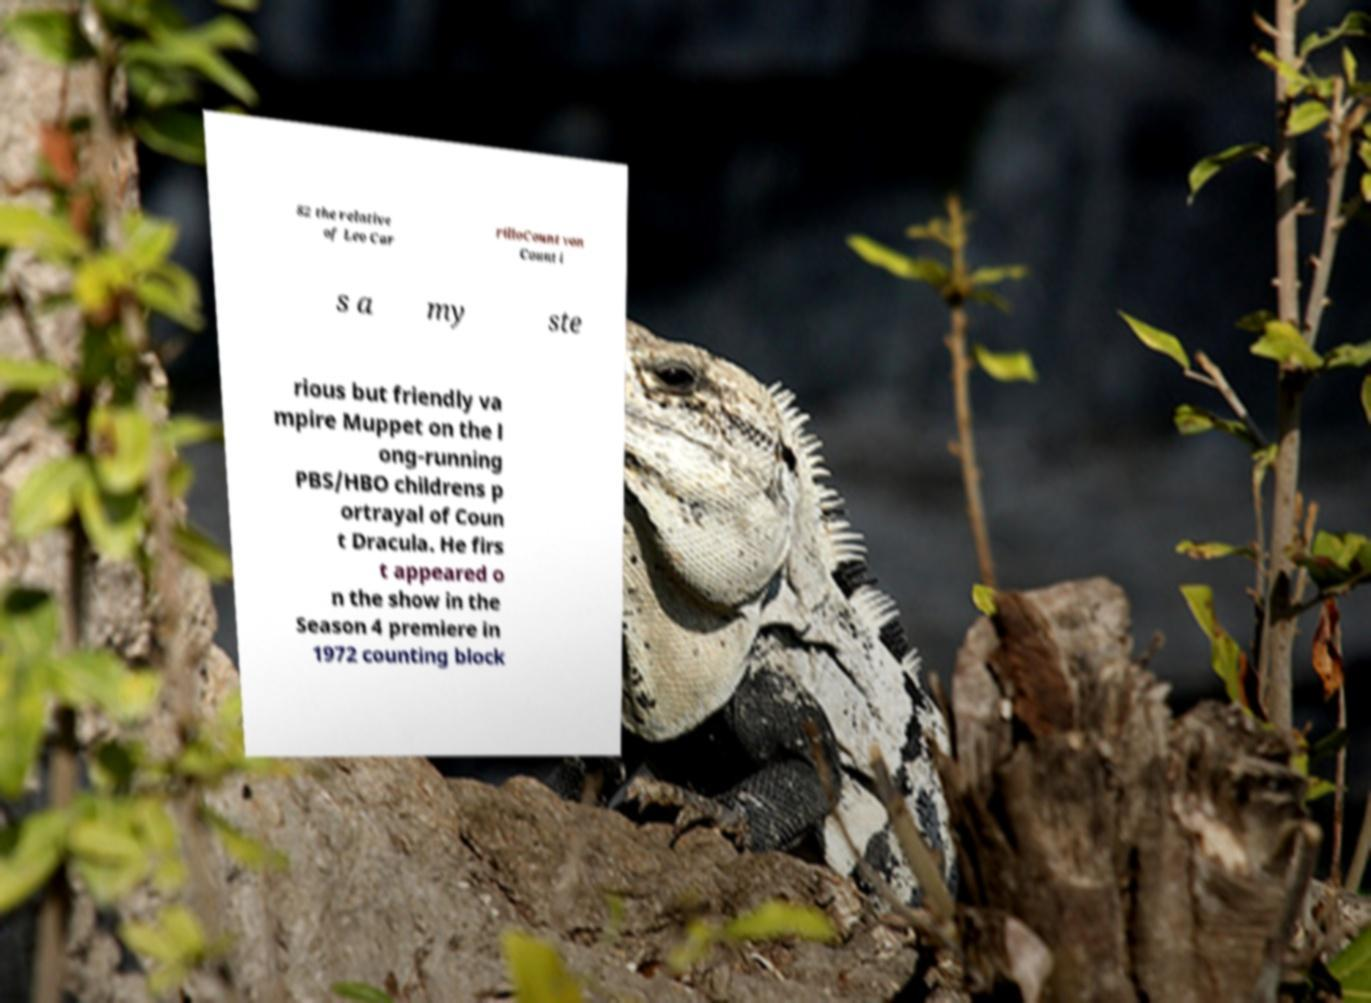Could you extract and type out the text from this image? 82 the relative of Leo Car rilloCount von Count i s a my ste rious but friendly va mpire Muppet on the l ong-running PBS/HBO childrens p ortrayal of Coun t Dracula. He firs t appeared o n the show in the Season 4 premiere in 1972 counting block 